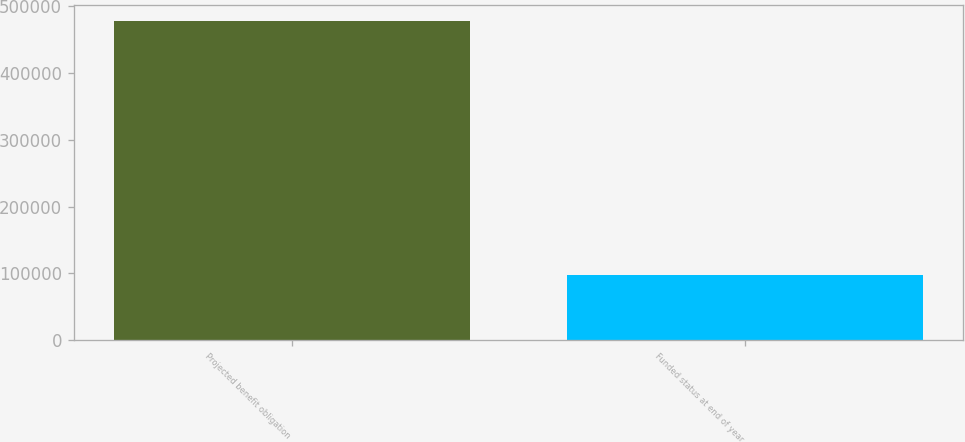Convert chart to OTSL. <chart><loc_0><loc_0><loc_500><loc_500><bar_chart><fcel>Projected benefit obligation<fcel>Funded status at end of year<nl><fcel>478136<fcel>97559<nl></chart> 